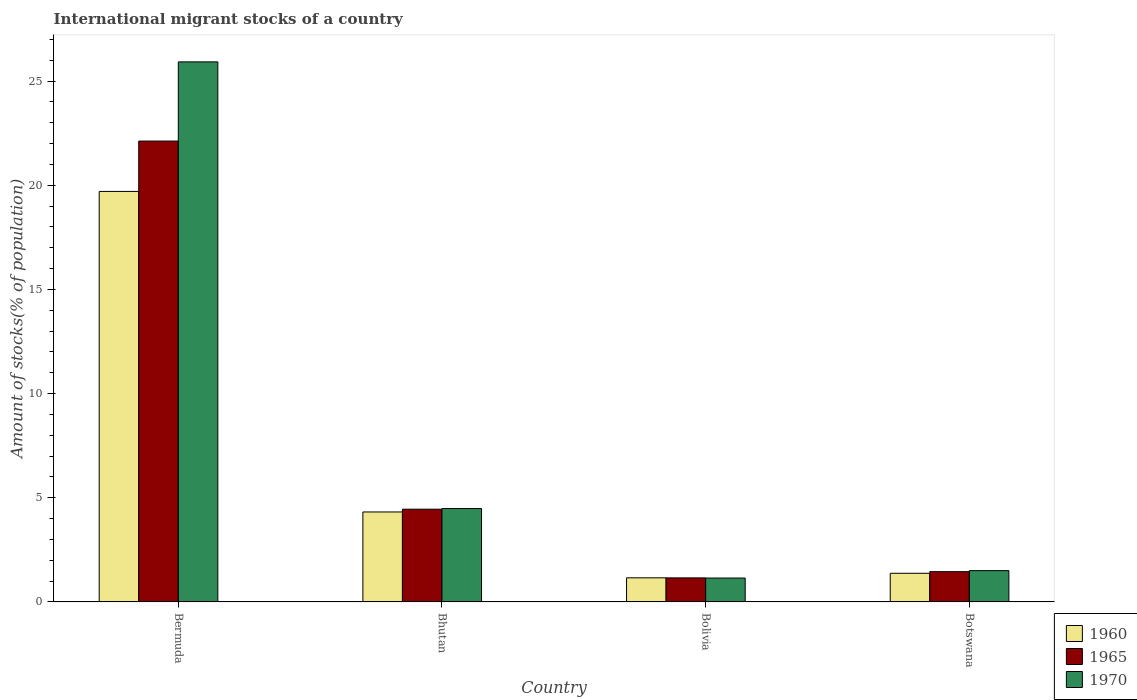How many groups of bars are there?
Ensure brevity in your answer.  4. Are the number of bars per tick equal to the number of legend labels?
Provide a short and direct response. Yes. Are the number of bars on each tick of the X-axis equal?
Provide a succinct answer. Yes. What is the label of the 3rd group of bars from the left?
Offer a terse response. Bolivia. What is the amount of stocks in in 1970 in Bhutan?
Provide a succinct answer. 4.48. Across all countries, what is the maximum amount of stocks in in 1960?
Give a very brief answer. 19.7. Across all countries, what is the minimum amount of stocks in in 1960?
Your response must be concise. 1.16. In which country was the amount of stocks in in 1960 maximum?
Offer a very short reply. Bermuda. In which country was the amount of stocks in in 1970 minimum?
Keep it short and to the point. Bolivia. What is the total amount of stocks in in 1970 in the graph?
Your answer should be very brief. 33.05. What is the difference between the amount of stocks in in 1970 in Bermuda and that in Bhutan?
Ensure brevity in your answer.  21.44. What is the difference between the amount of stocks in in 1965 in Bhutan and the amount of stocks in in 1970 in Bermuda?
Provide a short and direct response. -21.47. What is the average amount of stocks in in 1965 per country?
Your response must be concise. 7.29. What is the difference between the amount of stocks in of/in 1970 and amount of stocks in of/in 1960 in Bolivia?
Offer a very short reply. -0.01. What is the ratio of the amount of stocks in in 1960 in Bolivia to that in Botswana?
Provide a succinct answer. 0.84. Is the amount of stocks in in 1970 in Bolivia less than that in Botswana?
Keep it short and to the point. Yes. Is the difference between the amount of stocks in in 1970 in Bermuda and Bhutan greater than the difference between the amount of stocks in in 1960 in Bermuda and Bhutan?
Provide a short and direct response. Yes. What is the difference between the highest and the second highest amount of stocks in in 1970?
Make the answer very short. 21.44. What is the difference between the highest and the lowest amount of stocks in in 1965?
Keep it short and to the point. 20.97. What does the 1st bar from the right in Bhutan represents?
Ensure brevity in your answer.  1970. How many bars are there?
Offer a very short reply. 12. Are all the bars in the graph horizontal?
Ensure brevity in your answer.  No. Are the values on the major ticks of Y-axis written in scientific E-notation?
Offer a very short reply. No. How many legend labels are there?
Ensure brevity in your answer.  3. What is the title of the graph?
Your answer should be very brief. International migrant stocks of a country. Does "2003" appear as one of the legend labels in the graph?
Keep it short and to the point. No. What is the label or title of the Y-axis?
Give a very brief answer. Amount of stocks(% of population). What is the Amount of stocks(% of population) in 1960 in Bermuda?
Provide a succinct answer. 19.7. What is the Amount of stocks(% of population) of 1965 in Bermuda?
Provide a succinct answer. 22.12. What is the Amount of stocks(% of population) in 1970 in Bermuda?
Your response must be concise. 25.92. What is the Amount of stocks(% of population) of 1960 in Bhutan?
Your answer should be very brief. 4.32. What is the Amount of stocks(% of population) of 1965 in Bhutan?
Offer a terse response. 4.45. What is the Amount of stocks(% of population) of 1970 in Bhutan?
Provide a succinct answer. 4.48. What is the Amount of stocks(% of population) in 1960 in Bolivia?
Your answer should be very brief. 1.16. What is the Amount of stocks(% of population) of 1965 in Bolivia?
Your response must be concise. 1.15. What is the Amount of stocks(% of population) of 1970 in Bolivia?
Offer a terse response. 1.15. What is the Amount of stocks(% of population) of 1960 in Botswana?
Give a very brief answer. 1.37. What is the Amount of stocks(% of population) of 1965 in Botswana?
Offer a very short reply. 1.45. What is the Amount of stocks(% of population) in 1970 in Botswana?
Ensure brevity in your answer.  1.5. Across all countries, what is the maximum Amount of stocks(% of population) of 1960?
Ensure brevity in your answer.  19.7. Across all countries, what is the maximum Amount of stocks(% of population) in 1965?
Ensure brevity in your answer.  22.12. Across all countries, what is the maximum Amount of stocks(% of population) in 1970?
Keep it short and to the point. 25.92. Across all countries, what is the minimum Amount of stocks(% of population) in 1960?
Your response must be concise. 1.16. Across all countries, what is the minimum Amount of stocks(% of population) of 1965?
Offer a very short reply. 1.15. Across all countries, what is the minimum Amount of stocks(% of population) of 1970?
Keep it short and to the point. 1.15. What is the total Amount of stocks(% of population) in 1960 in the graph?
Offer a terse response. 26.55. What is the total Amount of stocks(% of population) in 1965 in the graph?
Ensure brevity in your answer.  29.18. What is the total Amount of stocks(% of population) of 1970 in the graph?
Give a very brief answer. 33.05. What is the difference between the Amount of stocks(% of population) of 1960 in Bermuda and that in Bhutan?
Ensure brevity in your answer.  15.39. What is the difference between the Amount of stocks(% of population) of 1965 in Bermuda and that in Bhutan?
Provide a succinct answer. 17.67. What is the difference between the Amount of stocks(% of population) in 1970 in Bermuda and that in Bhutan?
Offer a very short reply. 21.44. What is the difference between the Amount of stocks(% of population) of 1960 in Bermuda and that in Bolivia?
Make the answer very short. 18.55. What is the difference between the Amount of stocks(% of population) of 1965 in Bermuda and that in Bolivia?
Provide a short and direct response. 20.97. What is the difference between the Amount of stocks(% of population) of 1970 in Bermuda and that in Bolivia?
Provide a short and direct response. 24.78. What is the difference between the Amount of stocks(% of population) in 1960 in Bermuda and that in Botswana?
Ensure brevity in your answer.  18.33. What is the difference between the Amount of stocks(% of population) of 1965 in Bermuda and that in Botswana?
Offer a terse response. 20.67. What is the difference between the Amount of stocks(% of population) of 1970 in Bermuda and that in Botswana?
Keep it short and to the point. 24.42. What is the difference between the Amount of stocks(% of population) in 1960 in Bhutan and that in Bolivia?
Keep it short and to the point. 3.16. What is the difference between the Amount of stocks(% of population) of 1965 in Bhutan and that in Bolivia?
Give a very brief answer. 3.3. What is the difference between the Amount of stocks(% of population) of 1970 in Bhutan and that in Bolivia?
Make the answer very short. 3.34. What is the difference between the Amount of stocks(% of population) of 1960 in Bhutan and that in Botswana?
Make the answer very short. 2.94. What is the difference between the Amount of stocks(% of population) of 1965 in Bhutan and that in Botswana?
Offer a very short reply. 3. What is the difference between the Amount of stocks(% of population) of 1970 in Bhutan and that in Botswana?
Keep it short and to the point. 2.98. What is the difference between the Amount of stocks(% of population) in 1960 in Bolivia and that in Botswana?
Your answer should be very brief. -0.22. What is the difference between the Amount of stocks(% of population) in 1965 in Bolivia and that in Botswana?
Offer a very short reply. -0.3. What is the difference between the Amount of stocks(% of population) in 1970 in Bolivia and that in Botswana?
Your answer should be compact. -0.36. What is the difference between the Amount of stocks(% of population) in 1960 in Bermuda and the Amount of stocks(% of population) in 1965 in Bhutan?
Your answer should be very brief. 15.25. What is the difference between the Amount of stocks(% of population) of 1960 in Bermuda and the Amount of stocks(% of population) of 1970 in Bhutan?
Your answer should be very brief. 15.22. What is the difference between the Amount of stocks(% of population) of 1965 in Bermuda and the Amount of stocks(% of population) of 1970 in Bhutan?
Provide a succinct answer. 17.64. What is the difference between the Amount of stocks(% of population) in 1960 in Bermuda and the Amount of stocks(% of population) in 1965 in Bolivia?
Your response must be concise. 18.55. What is the difference between the Amount of stocks(% of population) of 1960 in Bermuda and the Amount of stocks(% of population) of 1970 in Bolivia?
Offer a very short reply. 18.56. What is the difference between the Amount of stocks(% of population) in 1965 in Bermuda and the Amount of stocks(% of population) in 1970 in Bolivia?
Give a very brief answer. 20.98. What is the difference between the Amount of stocks(% of population) of 1960 in Bermuda and the Amount of stocks(% of population) of 1965 in Botswana?
Provide a succinct answer. 18.25. What is the difference between the Amount of stocks(% of population) of 1960 in Bermuda and the Amount of stocks(% of population) of 1970 in Botswana?
Provide a short and direct response. 18.2. What is the difference between the Amount of stocks(% of population) in 1965 in Bermuda and the Amount of stocks(% of population) in 1970 in Botswana?
Ensure brevity in your answer.  20.62. What is the difference between the Amount of stocks(% of population) in 1960 in Bhutan and the Amount of stocks(% of population) in 1965 in Bolivia?
Ensure brevity in your answer.  3.16. What is the difference between the Amount of stocks(% of population) of 1960 in Bhutan and the Amount of stocks(% of population) of 1970 in Bolivia?
Offer a very short reply. 3.17. What is the difference between the Amount of stocks(% of population) in 1965 in Bhutan and the Amount of stocks(% of population) in 1970 in Bolivia?
Your response must be concise. 3.31. What is the difference between the Amount of stocks(% of population) in 1960 in Bhutan and the Amount of stocks(% of population) in 1965 in Botswana?
Your answer should be very brief. 2.86. What is the difference between the Amount of stocks(% of population) in 1960 in Bhutan and the Amount of stocks(% of population) in 1970 in Botswana?
Make the answer very short. 2.82. What is the difference between the Amount of stocks(% of population) of 1965 in Bhutan and the Amount of stocks(% of population) of 1970 in Botswana?
Keep it short and to the point. 2.95. What is the difference between the Amount of stocks(% of population) in 1960 in Bolivia and the Amount of stocks(% of population) in 1965 in Botswana?
Keep it short and to the point. -0.3. What is the difference between the Amount of stocks(% of population) of 1960 in Bolivia and the Amount of stocks(% of population) of 1970 in Botswana?
Offer a very short reply. -0.34. What is the difference between the Amount of stocks(% of population) in 1965 in Bolivia and the Amount of stocks(% of population) in 1970 in Botswana?
Offer a terse response. -0.35. What is the average Amount of stocks(% of population) in 1960 per country?
Your answer should be compact. 6.64. What is the average Amount of stocks(% of population) of 1965 per country?
Your response must be concise. 7.29. What is the average Amount of stocks(% of population) of 1970 per country?
Provide a short and direct response. 8.26. What is the difference between the Amount of stocks(% of population) in 1960 and Amount of stocks(% of population) in 1965 in Bermuda?
Keep it short and to the point. -2.42. What is the difference between the Amount of stocks(% of population) of 1960 and Amount of stocks(% of population) of 1970 in Bermuda?
Provide a short and direct response. -6.22. What is the difference between the Amount of stocks(% of population) of 1965 and Amount of stocks(% of population) of 1970 in Bermuda?
Offer a terse response. -3.8. What is the difference between the Amount of stocks(% of population) in 1960 and Amount of stocks(% of population) in 1965 in Bhutan?
Provide a short and direct response. -0.13. What is the difference between the Amount of stocks(% of population) of 1960 and Amount of stocks(% of population) of 1970 in Bhutan?
Provide a succinct answer. -0.16. What is the difference between the Amount of stocks(% of population) in 1965 and Amount of stocks(% of population) in 1970 in Bhutan?
Keep it short and to the point. -0.03. What is the difference between the Amount of stocks(% of population) in 1960 and Amount of stocks(% of population) in 1965 in Bolivia?
Offer a terse response. 0. What is the difference between the Amount of stocks(% of population) in 1960 and Amount of stocks(% of population) in 1970 in Bolivia?
Your answer should be very brief. 0.01. What is the difference between the Amount of stocks(% of population) of 1965 and Amount of stocks(% of population) of 1970 in Bolivia?
Ensure brevity in your answer.  0.01. What is the difference between the Amount of stocks(% of population) of 1960 and Amount of stocks(% of population) of 1965 in Botswana?
Provide a succinct answer. -0.08. What is the difference between the Amount of stocks(% of population) in 1960 and Amount of stocks(% of population) in 1970 in Botswana?
Your answer should be compact. -0.13. What is the difference between the Amount of stocks(% of population) of 1965 and Amount of stocks(% of population) of 1970 in Botswana?
Ensure brevity in your answer.  -0.05. What is the ratio of the Amount of stocks(% of population) in 1960 in Bermuda to that in Bhutan?
Give a very brief answer. 4.56. What is the ratio of the Amount of stocks(% of population) of 1965 in Bermuda to that in Bhutan?
Make the answer very short. 4.97. What is the ratio of the Amount of stocks(% of population) in 1970 in Bermuda to that in Bhutan?
Offer a very short reply. 5.78. What is the ratio of the Amount of stocks(% of population) of 1960 in Bermuda to that in Bolivia?
Your answer should be very brief. 17.04. What is the ratio of the Amount of stocks(% of population) of 1965 in Bermuda to that in Bolivia?
Make the answer very short. 19.18. What is the ratio of the Amount of stocks(% of population) of 1970 in Bermuda to that in Bolivia?
Offer a terse response. 22.64. What is the ratio of the Amount of stocks(% of population) of 1960 in Bermuda to that in Botswana?
Make the answer very short. 14.34. What is the ratio of the Amount of stocks(% of population) in 1965 in Bermuda to that in Botswana?
Provide a succinct answer. 15.23. What is the ratio of the Amount of stocks(% of population) in 1970 in Bermuda to that in Botswana?
Your response must be concise. 17.27. What is the ratio of the Amount of stocks(% of population) of 1960 in Bhutan to that in Bolivia?
Your answer should be very brief. 3.73. What is the ratio of the Amount of stocks(% of population) of 1965 in Bhutan to that in Bolivia?
Provide a succinct answer. 3.86. What is the ratio of the Amount of stocks(% of population) of 1970 in Bhutan to that in Bolivia?
Offer a terse response. 3.91. What is the ratio of the Amount of stocks(% of population) in 1960 in Bhutan to that in Botswana?
Your answer should be very brief. 3.14. What is the ratio of the Amount of stocks(% of population) of 1965 in Bhutan to that in Botswana?
Offer a very short reply. 3.06. What is the ratio of the Amount of stocks(% of population) in 1970 in Bhutan to that in Botswana?
Provide a short and direct response. 2.99. What is the ratio of the Amount of stocks(% of population) of 1960 in Bolivia to that in Botswana?
Your answer should be compact. 0.84. What is the ratio of the Amount of stocks(% of population) of 1965 in Bolivia to that in Botswana?
Ensure brevity in your answer.  0.79. What is the ratio of the Amount of stocks(% of population) of 1970 in Bolivia to that in Botswana?
Provide a succinct answer. 0.76. What is the difference between the highest and the second highest Amount of stocks(% of population) in 1960?
Give a very brief answer. 15.39. What is the difference between the highest and the second highest Amount of stocks(% of population) of 1965?
Ensure brevity in your answer.  17.67. What is the difference between the highest and the second highest Amount of stocks(% of population) of 1970?
Your answer should be very brief. 21.44. What is the difference between the highest and the lowest Amount of stocks(% of population) of 1960?
Your answer should be compact. 18.55. What is the difference between the highest and the lowest Amount of stocks(% of population) of 1965?
Your response must be concise. 20.97. What is the difference between the highest and the lowest Amount of stocks(% of population) in 1970?
Make the answer very short. 24.78. 